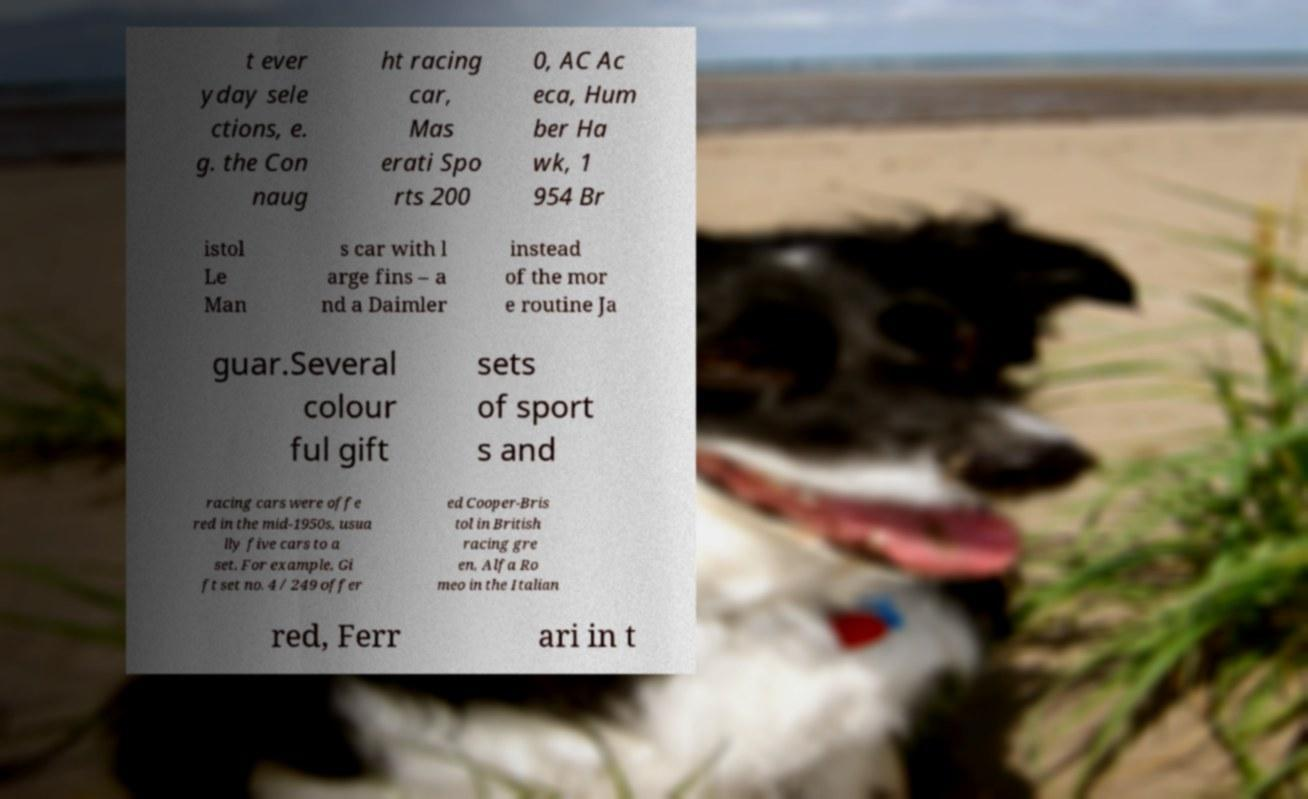What messages or text are displayed in this image? I need them in a readable, typed format. t ever yday sele ctions, e. g. the Con naug ht racing car, Mas erati Spo rts 200 0, AC Ac eca, Hum ber Ha wk, 1 954 Br istol Le Man s car with l arge fins – a nd a Daimler instead of the mor e routine Ja guar.Several colour ful gift sets of sport s and racing cars were offe red in the mid-1950s, usua lly five cars to a set. For example, Gi ft set no. 4 / 249 offer ed Cooper-Bris tol in British racing gre en, Alfa Ro meo in the Italian red, Ferr ari in t 